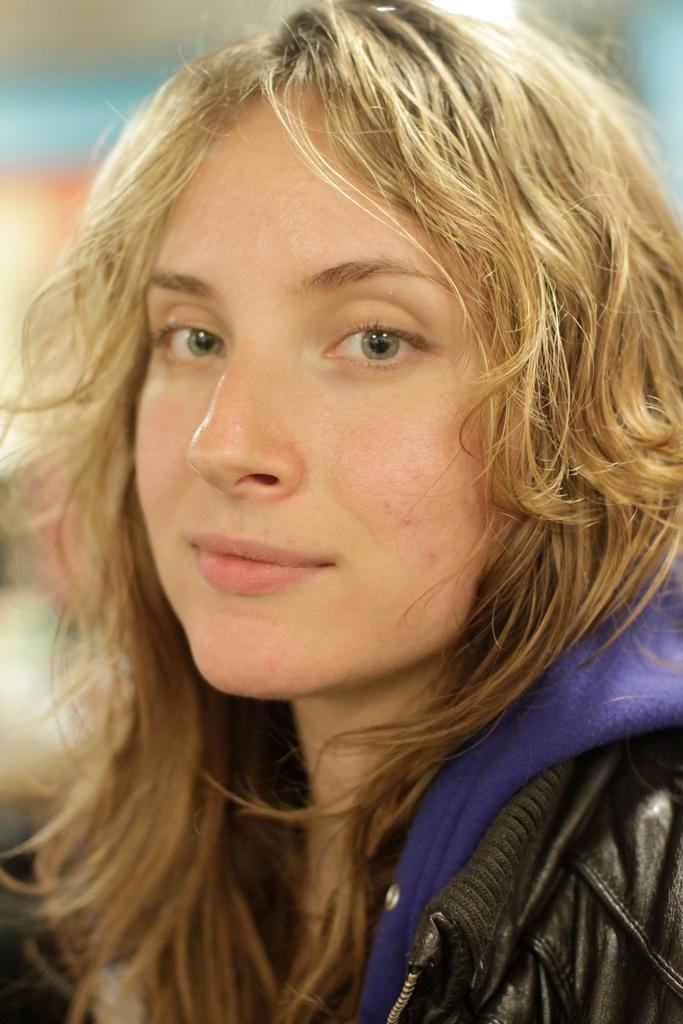What is the main subject of the image? The main subject of the image is a woman. What is the woman wearing in the image? The woman is wearing a black jacket in the image. Can you describe the woman's hair in the image? The woman has blonde hair in the image. How many sheep are visible in the image? There are no sheep present in the image. What type of mint can be seen growing in the image? There is no mint visible in the image. 